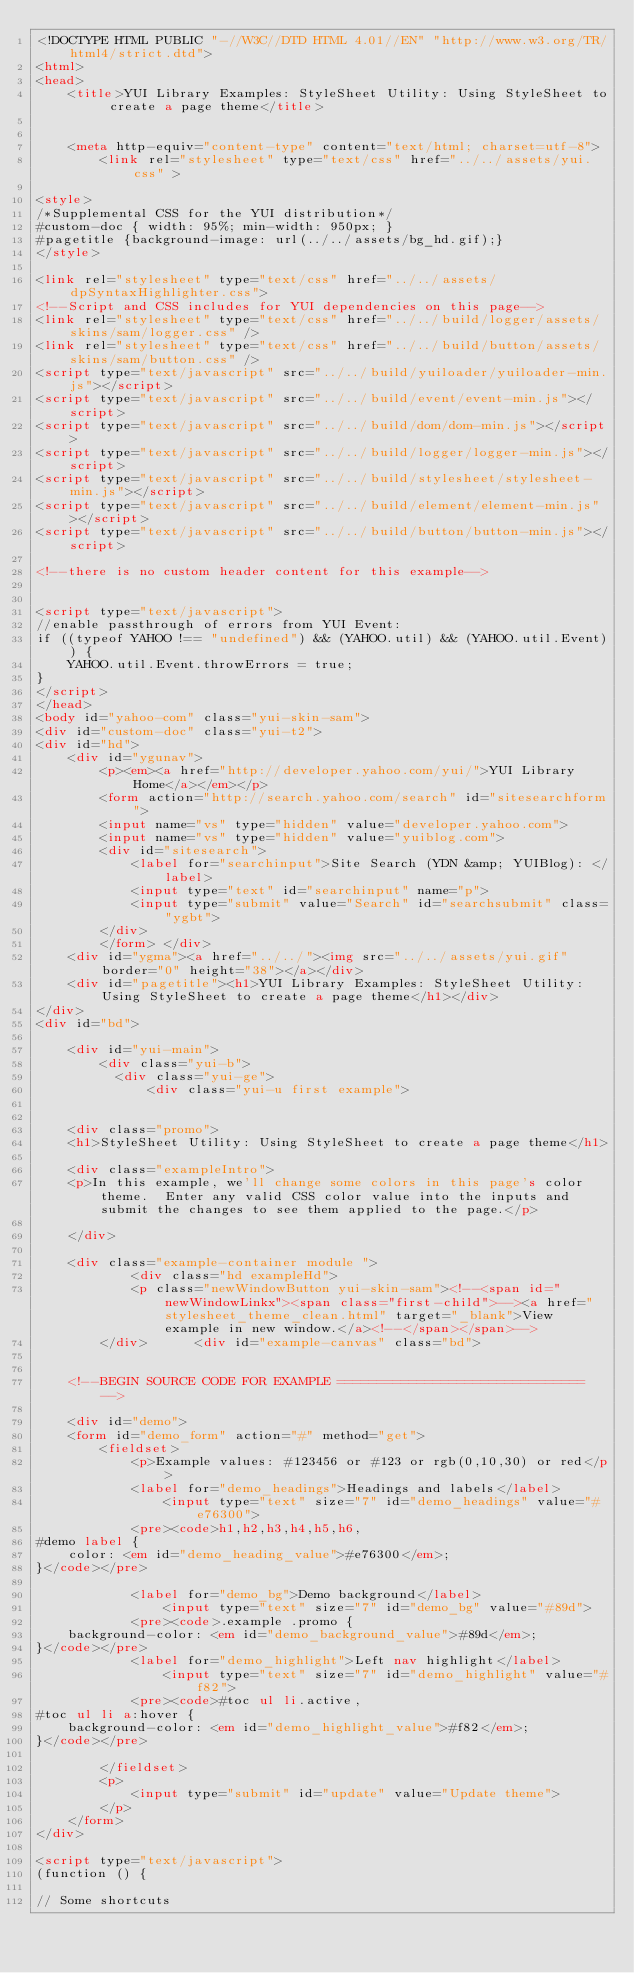Convert code to text. <code><loc_0><loc_0><loc_500><loc_500><_HTML_><!DOCTYPE HTML PUBLIC "-//W3C//DTD HTML 4.01//EN" "http://www.w3.org/TR/html4/strict.dtd">
<html>
<head>
	<title>YUI Library Examples: StyleSheet Utility: Using StyleSheet to create a page theme</title>
    

    <meta http-equiv="content-type" content="text/html; charset=utf-8">
    	<link rel="stylesheet" type="text/css" href="../../assets/yui.css" >

<style>
/*Supplemental CSS for the YUI distribution*/
#custom-doc { width: 95%; min-width: 950px; }
#pagetitle {background-image: url(../../assets/bg_hd.gif);}
</style>

<link rel="stylesheet" type="text/css" href="../../assets/dpSyntaxHighlighter.css">
<!--Script and CSS includes for YUI dependencies on this page-->
<link rel="stylesheet" type="text/css" href="../../build/logger/assets/skins/sam/logger.css" />
<link rel="stylesheet" type="text/css" href="../../build/button/assets/skins/sam/button.css" />
<script type="text/javascript" src="../../build/yuiloader/yuiloader-min.js"></script>
<script type="text/javascript" src="../../build/event/event-min.js"></script>
<script type="text/javascript" src="../../build/dom/dom-min.js"></script>
<script type="text/javascript" src="../../build/logger/logger-min.js"></script>
<script type="text/javascript" src="../../build/stylesheet/stylesheet-min.js"></script>
<script type="text/javascript" src="../../build/element/element-min.js"></script>
<script type="text/javascript" src="../../build/button/button-min.js"></script>

<!--there is no custom header content for this example-->


<script type="text/javascript">
//enable passthrough of errors from YUI Event:
if ((typeof YAHOO !== "undefined") && (YAHOO.util) && (YAHOO.util.Event)) {
	YAHOO.util.Event.throwErrors = true;
}
</script>
</head>
<body id="yahoo-com" class="yui-skin-sam">
<div id="custom-doc" class="yui-t2">
<div id="hd">
	<div id="ygunav">
		<p><em><a href="http://developer.yahoo.com/yui/">YUI Library Home</a></em></p>
		<form action="http://search.yahoo.com/search" id="sitesearchform">
		<input name="vs" type="hidden" value="developer.yahoo.com">
		<input name="vs" type="hidden" value="yuiblog.com">
		<div id="sitesearch">
			<label for="searchinput">Site Search (YDN &amp; YUIBlog): </label>
			<input type="text" id="searchinput" name="p">
			<input type="submit" value="Search" id="searchsubmit" class="ygbt">
		</div>
		</form>	</div>
	<div id="ygma"><a href="../../"><img src="../../assets/yui.gif"  border="0" height="38"></a></div>
	<div id="pagetitle"><h1>YUI Library Examples: StyleSheet Utility: Using StyleSheet to create a page theme</h1></div>
</div>
<div id="bd">
	
	<div id="yui-main">
		<div class="yui-b">
		  <div class="yui-ge">
			  <div class="yui-u first example">

    
	<div class="promo">
	<h1>StyleSheet Utility: Using StyleSheet to create a page theme</h1>
	
	<div class="exampleIntro">
	<p>In this example, we'll change some colors in this page's color theme.  Enter any valid CSS color value into the inputs and submit the changes to see them applied to the page.</p>
			
	</div>	
					
	<div class="example-container module ">
			<div class="hd exampleHd">
			<p class="newWindowButton yui-skin-sam"><!--<span id="newWindowLinkx"><span class="first-child">--><a href="stylesheet_theme_clean.html" target="_blank">View example in new window.</a><!--</span></span>-->		
		</div>		<div id="example-canvas" class="bd">
	
		
	<!--BEGIN SOURCE CODE FOR EXAMPLE =============================== -->
	
	<div id="demo">
    <form id="demo_form" action="#" method="get">
        <fieldset>
            <p>Example values: #123456 or #123 or rgb(0,10,30) or red</p>
            <label for="demo_headings">Headings and labels</label>
                <input type="text" size="7" id="demo_headings" value="#e76300">
            <pre><code>h1,h2,h3,h4,h5,h6,
#demo label {
    color: <em id="demo_heading_value">#e76300</em>;
}</code></pre>

            <label for="demo_bg">Demo background</label>
                <input type="text" size="7" id="demo_bg" value="#89d">
            <pre><code>.example .promo {
    background-color: <em id="demo_background_value">#89d</em>;
}</code></pre>
            <label for="demo_highlight">Left nav highlight</label>
                <input type="text" size="7" id="demo_highlight" value="#f82">
            <pre><code>#toc ul li.active,
#toc ul li a:hover {
    background-color: <em id="demo_highlight_value">#f82</em>;
}</code></pre>

        </fieldset>
        <p>
            <input type="submit" id="update" value="Update theme">
        </p>
    </form>
</div>

<script type="text/javascript">
(function () {

// Some shortcuts</code> 